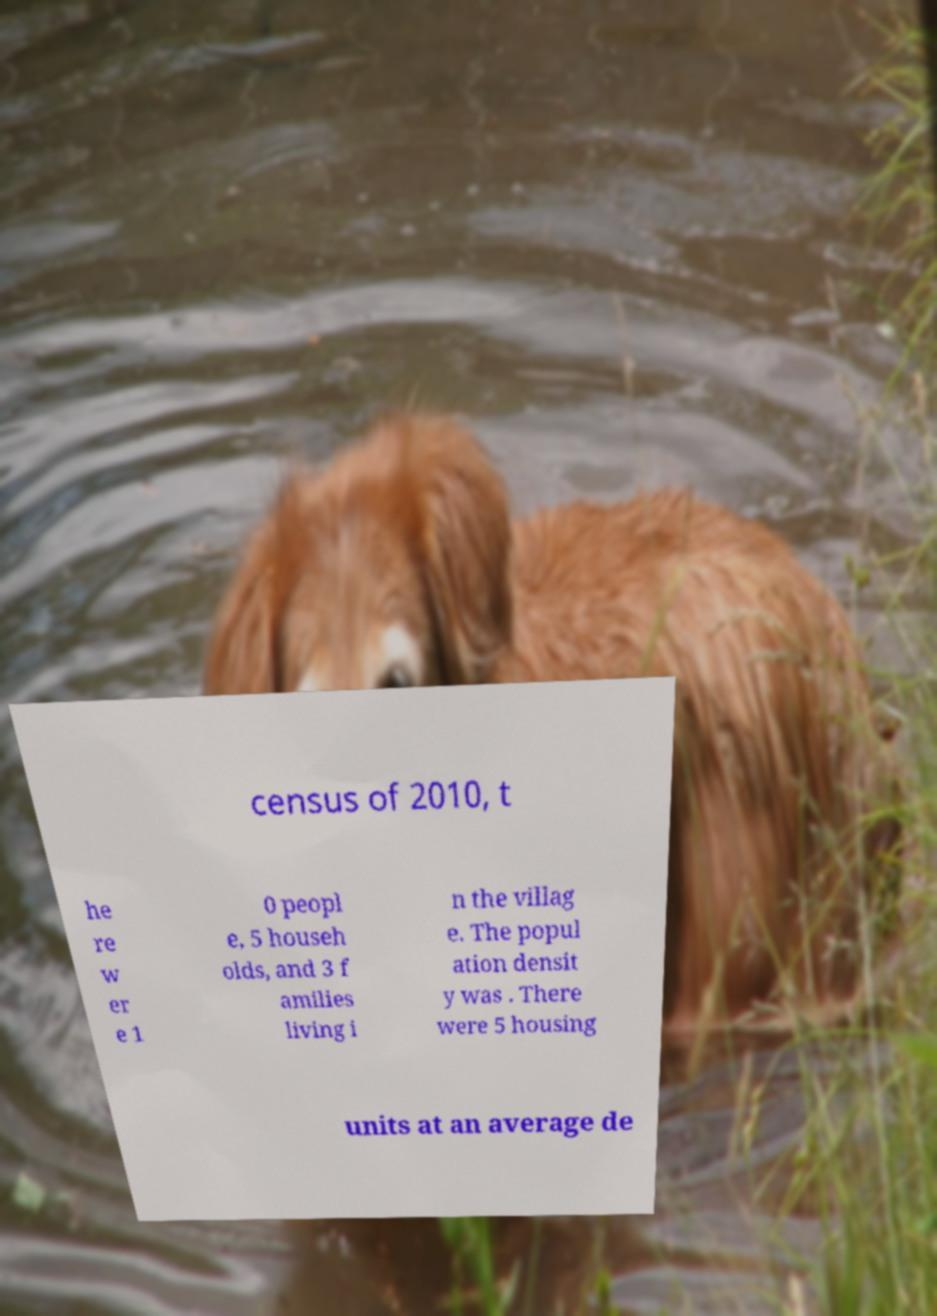Could you assist in decoding the text presented in this image and type it out clearly? census of 2010, t he re w er e 1 0 peopl e, 5 househ olds, and 3 f amilies living i n the villag e. The popul ation densit y was . There were 5 housing units at an average de 